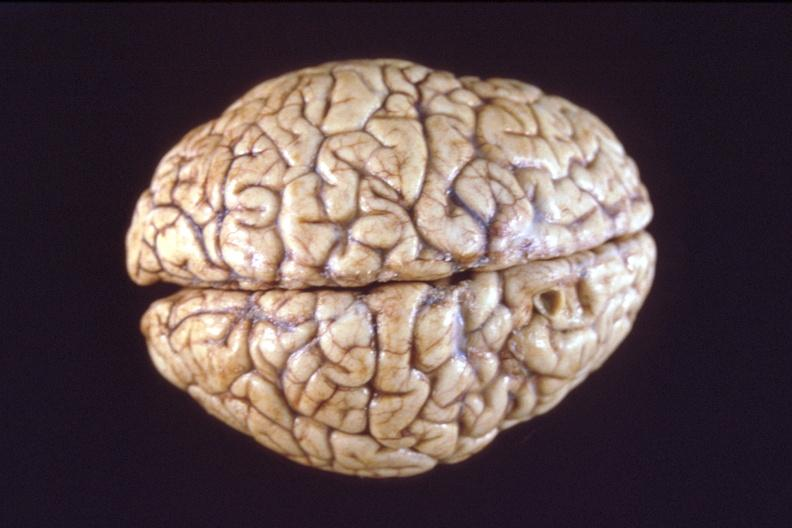what does this image show?
Answer the question using a single word or phrase. Brain 